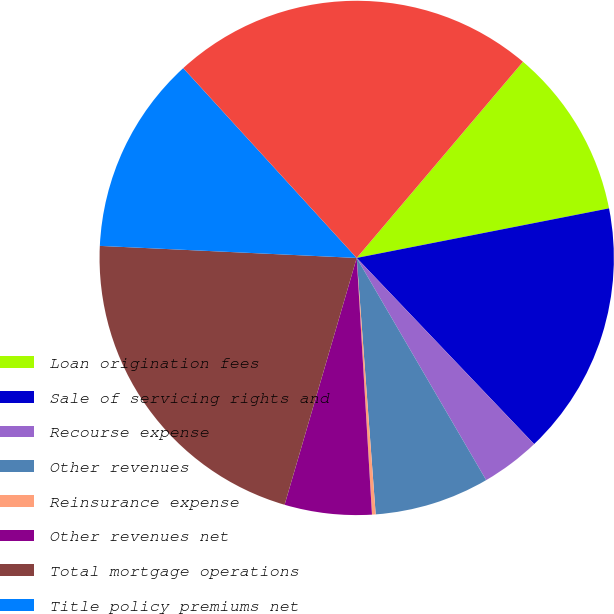<chart> <loc_0><loc_0><loc_500><loc_500><pie_chart><fcel>Loan origination fees<fcel>Sale of servicing rights and<fcel>Recourse expense<fcel>Other revenues<fcel>Reinsurance expense<fcel>Other revenues net<fcel>Total mortgage operations<fcel>Title policy premiums net<fcel>Total revenues<nl><fcel>10.72%<fcel>15.97%<fcel>3.72%<fcel>7.22%<fcel>0.23%<fcel>5.47%<fcel>21.22%<fcel>12.47%<fcel>22.97%<nl></chart> 